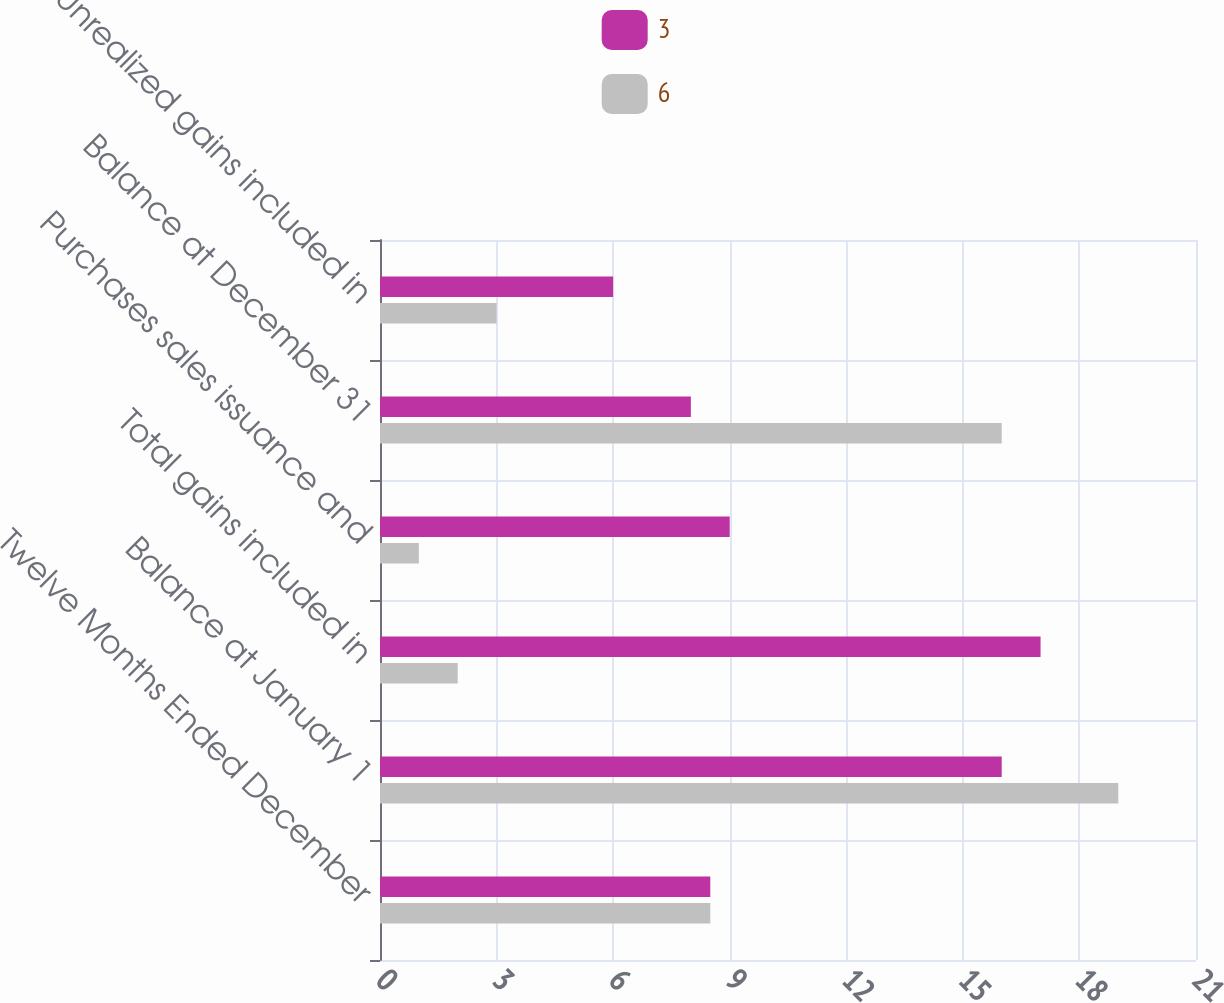Convert chart to OTSL. <chart><loc_0><loc_0><loc_500><loc_500><stacked_bar_chart><ecel><fcel>Twelve Months Ended December<fcel>Balance at January 1<fcel>Total gains included in<fcel>Purchases sales issuance and<fcel>Balance at December 31<fcel>Unrealized gains included in<nl><fcel>3<fcel>8.5<fcel>16<fcel>17<fcel>9<fcel>8<fcel>6<nl><fcel>6<fcel>8.5<fcel>19<fcel>2<fcel>1<fcel>16<fcel>3<nl></chart> 